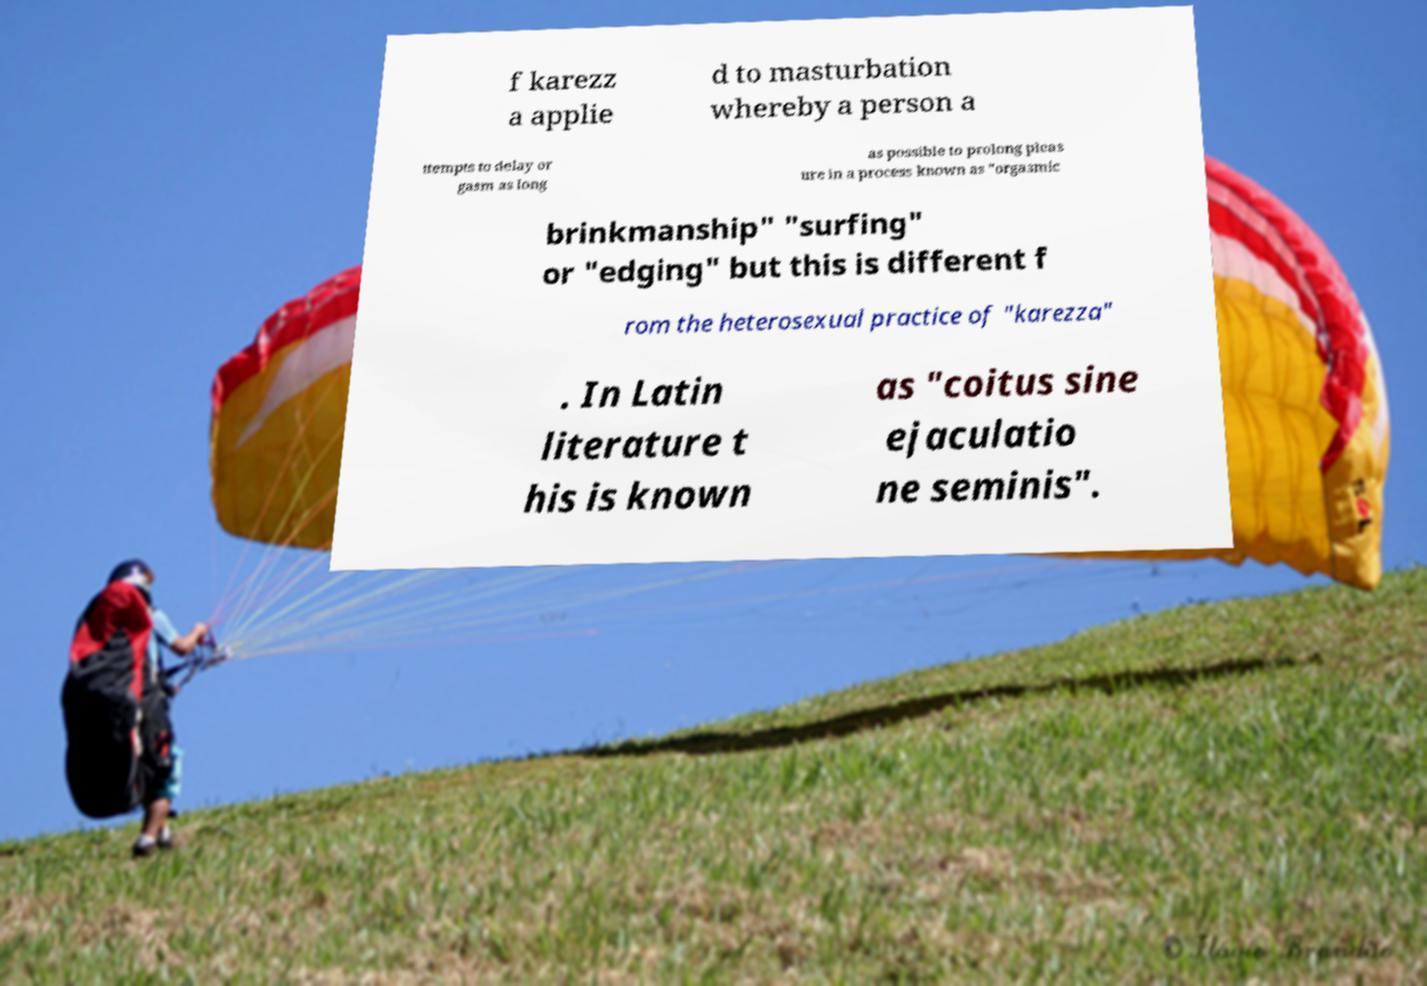Please identify and transcribe the text found in this image. f karezz a applie d to masturbation whereby a person a ttempts to delay or gasm as long as possible to prolong pleas ure in a process known as "orgasmic brinkmanship" "surfing" or "edging" but this is different f rom the heterosexual practice of "karezza" . In Latin literature t his is known as "coitus sine ejaculatio ne seminis". 